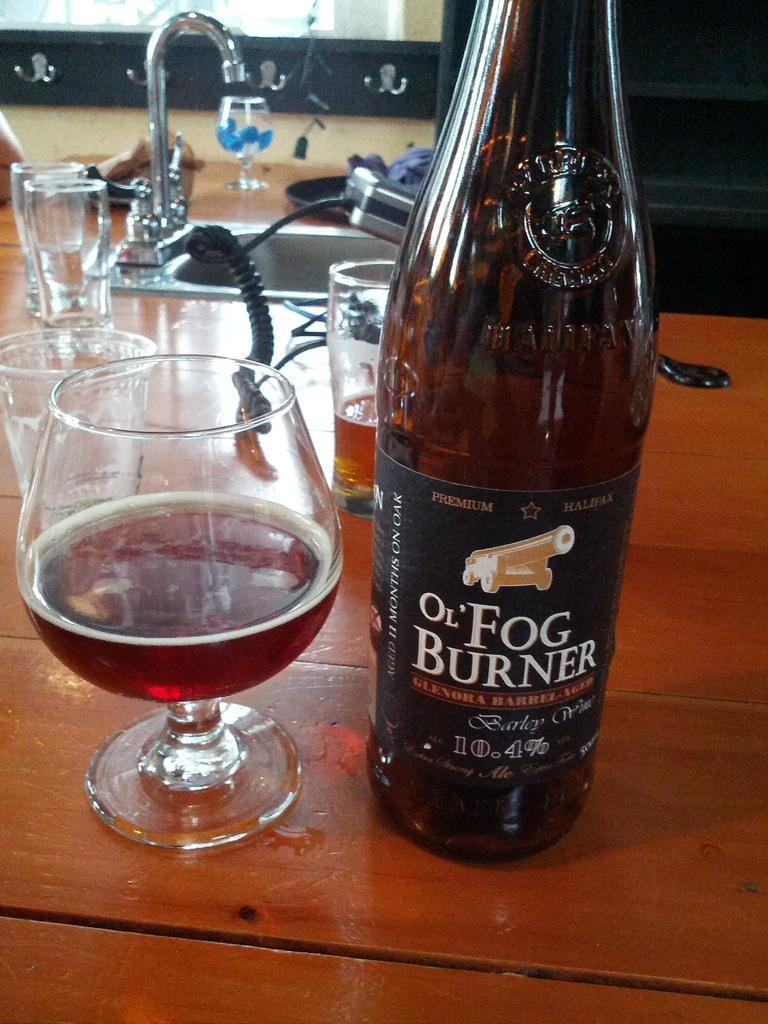Describe this image in one or two sentences. In this picture there is a wine glass and glass bottle on the wooden table. On background of them there is a tap and a sink in silver color. 